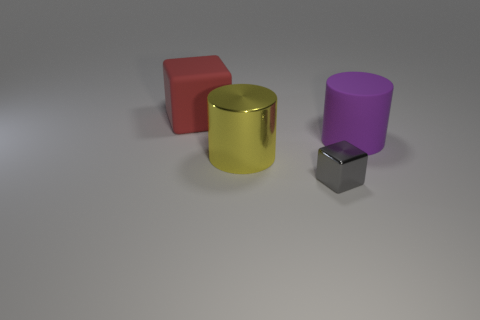What material is the yellow thing that is the same size as the red thing?
Your answer should be very brief. Metal. There is a big rubber thing that is behind the cylinder that is right of the shiny thing that is left of the small gray block; what is its color?
Offer a very short reply. Red. What is the color of the big block that is made of the same material as the large purple object?
Your answer should be very brief. Red. Are there any other things that have the same size as the gray object?
Your answer should be compact. No. What number of things are blocks that are in front of the purple matte thing or metal things in front of the large metallic cylinder?
Ensure brevity in your answer.  1. Does the matte thing that is behind the big purple object have the same size as the yellow object to the right of the large cube?
Offer a terse response. Yes. There is another matte thing that is the same shape as the tiny gray object; what color is it?
Give a very brief answer. Red. Is the number of big blocks that are right of the red cube greater than the number of small blocks that are to the right of the big purple rubber cylinder?
Ensure brevity in your answer.  No. There is a cube on the right side of the big thing that is in front of the big matte object that is in front of the red block; how big is it?
Make the answer very short. Small. Are the purple object and the big cylinder in front of the big purple matte cylinder made of the same material?
Keep it short and to the point. No. 